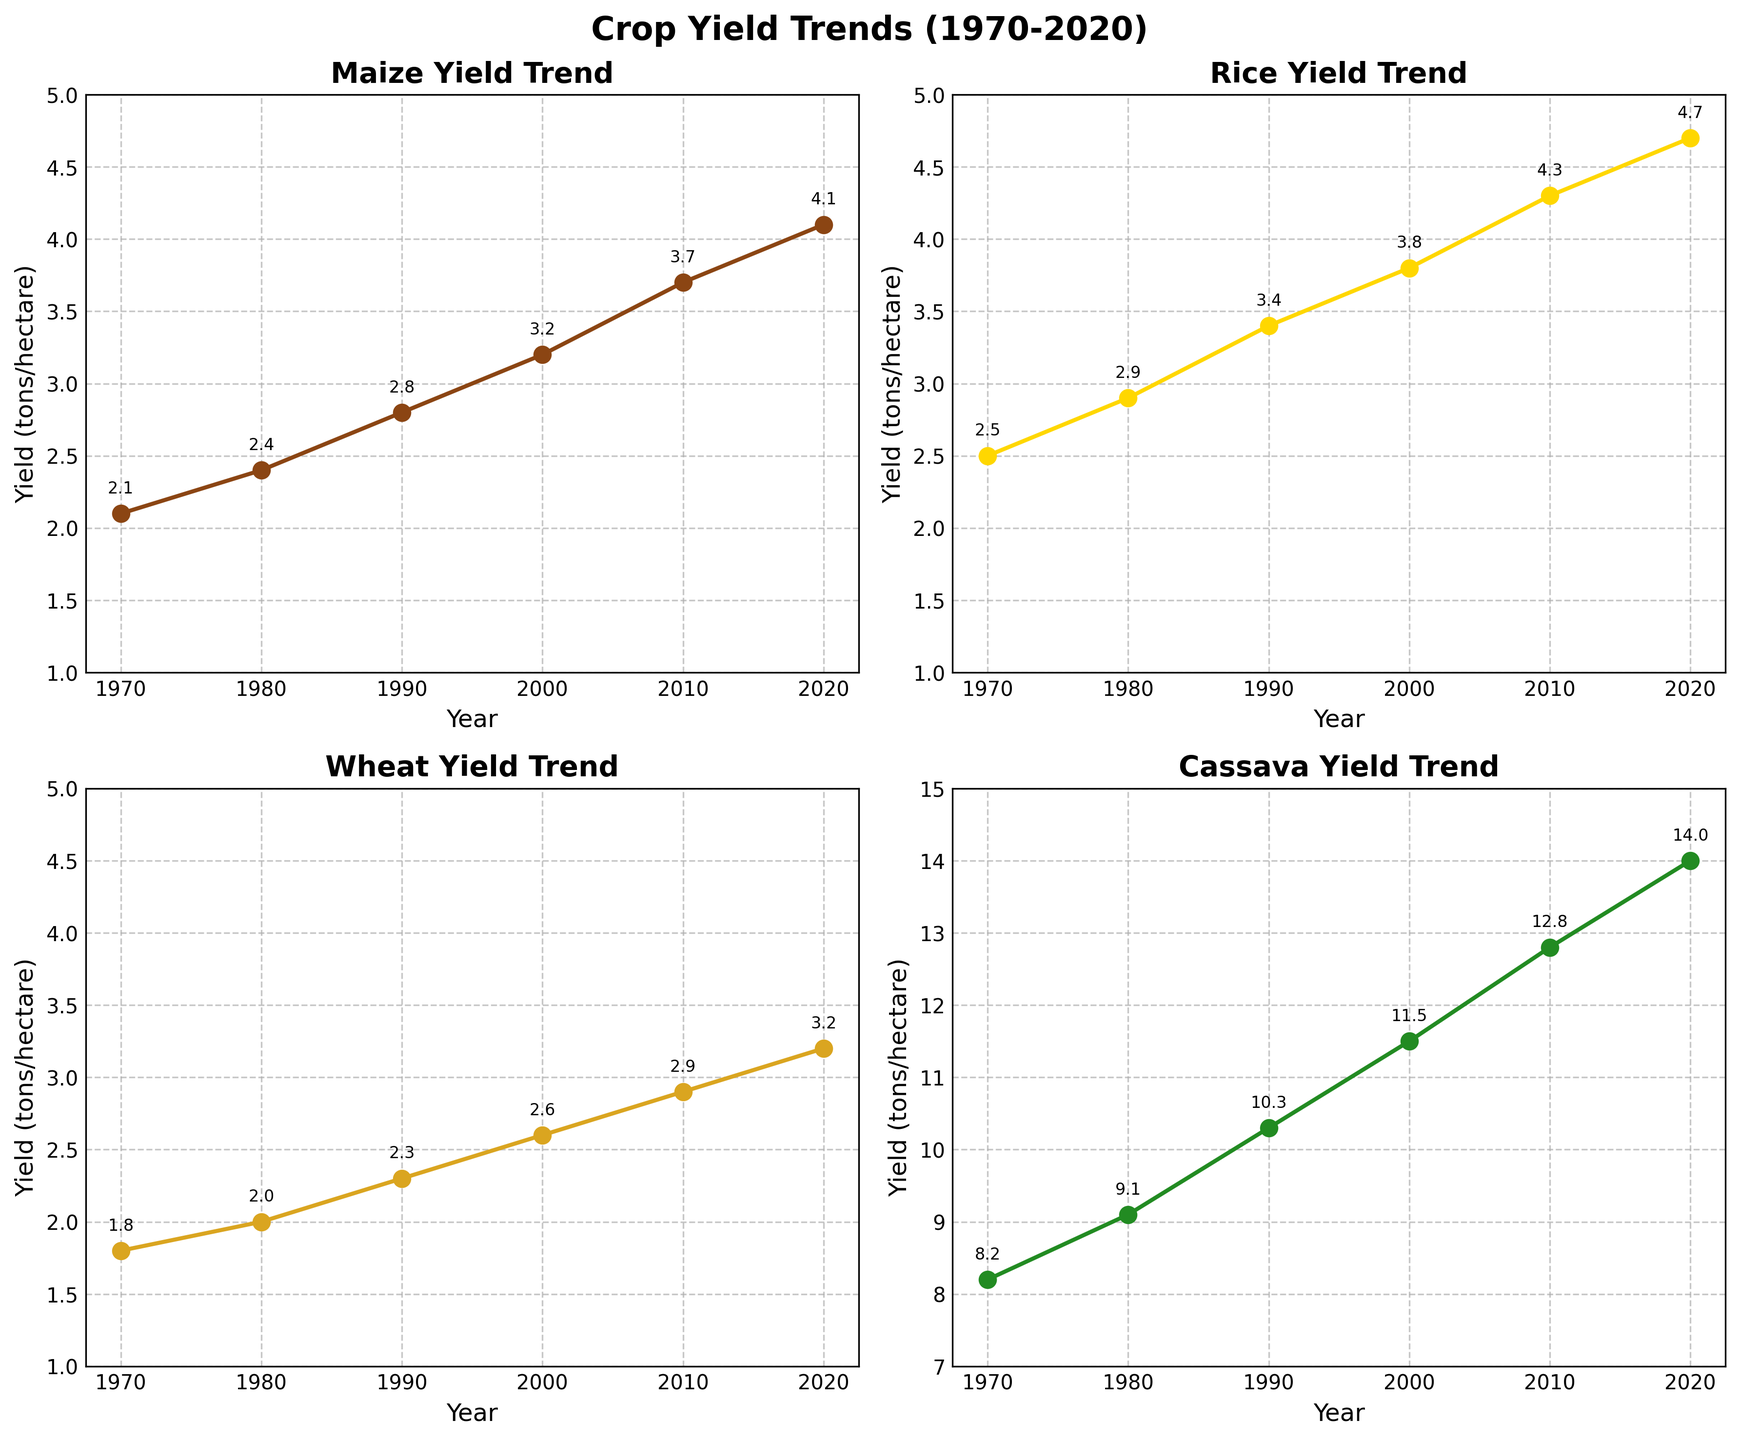What is the title of the overall figure? The title of the overall figure is located at the top and reads "Crop Yield Trends (1970-2020)", providing a summary of what the subplots collectively represent.
Answer: Crop Yield Trends (1970-2020) How many subplots are shown in the figure, and what are they about? The figure consists of four subplots, each representing the yield trend of a specific crop: Maize, Rice, Wheat, and Cassava.
Answer: Four, showing yield trends for Maize, Rice, Wheat, and Cassava Which crop has the highest yield in 2020, and what is its value? By examining the figure, Cassava has the highest yield in 2020, with a value of 14.0 tons/hectare as annotated on the Cassava subplot.
Answer: Cassava, 14.0 What is the trend for Maize yields from 1970 to 2020? Observing the Maize subplot, the yield shows a consistent increasing trend from 2.1 tons/hectare in 1970 to 4.1 tons/hectare in 2020.
Answer: Increasing Compare the yield of Rice in 1990 to that of Wheat in the same year. Which one is higher? In 1990, the yield of Rice is 3.4 tons/hectare, while the yield of Wheat is 2.3 tons/hectare. Therefore, Rice has a higher yield than Wheat in that year.
Answer: Rice What is the difference in the yield of Cassava between the years 1970 and 2020? The yield of Cassava in 1970 is 8.2 tons/hectare, and in 2020 it is 14.0 tons/hectare. The difference in yield is calculated as 14.0 - 8.2 = 5.8 tons/hectare.
Answer: 5.8 Between 1980 and 2000, which crop shows the highest rate of yield increase? Calculating the rate of increase for each crop: 
- Maize: 3.2 - 2.4 = 0.8
- Rice: 3.8 - 2.9 = 0.9
- Wheat: 2.6 - 2.0 = 0.6
- Cassava: 11.5 - 9.1 = 2.4
Cassava shows the highest rate of yield increase.
Answer: Cassava Which subplot shows the least variation in yields over the years? By visually comparing the range of yields in each subplot, Wheat shows the least variation with yields ranging from 1.8 to 3.2 tons/hectare over the period.
Answer: Wheat What is the average yield of Rice across all years shown? To find the average yield of Rice: (2.5 + 2.9 + 3.4 + 3.8 + 4.3 + 4.7) / 6 = 21.6 / 6 = 3.6 tons/hectare.
Answer: 3.6 Which crop had the least significant change in yield between 2010 and 2020? The change in yield from 2010 to 2020 for each crop is calculated:
- Maize: 4.1 - 3.7 = 0.4
- Rice: 4.7 - 4.3 = 0.4
- Wheat: 3.2 - 2.9 = 0.3
- Cassava: 14.0 - 12.8 = 1.2
Wheat had the least significant change with a difference of 0.3 tons/hectare.
Answer: Wheat 